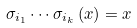<formula> <loc_0><loc_0><loc_500><loc_500>\sigma _ { i _ { 1 } } \cdots \sigma _ { i _ { k } } \left ( x \right ) = x</formula> 